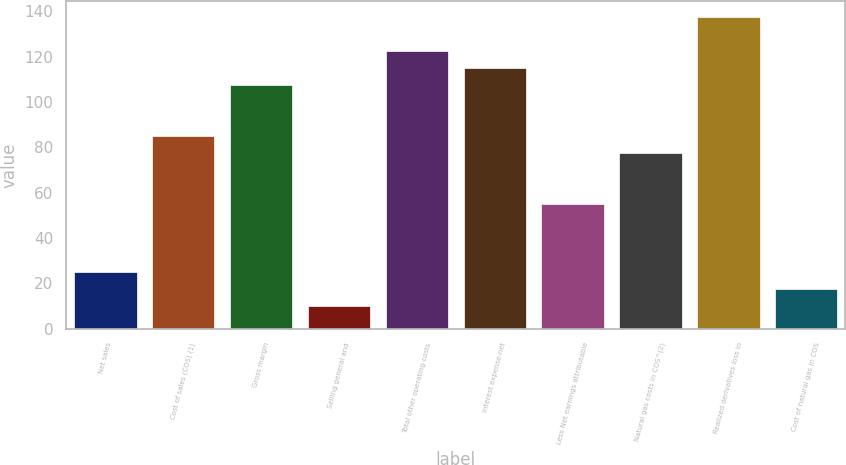Convert chart to OTSL. <chart><loc_0><loc_0><loc_500><loc_500><bar_chart><fcel>Net sales<fcel>Cost of sales (COS) (1)<fcel>Gross margin<fcel>Selling general and<fcel>Total other operating costs<fcel>Interest expense-net<fcel>Less Net earnings attributable<fcel>Natural gas costs in COS^(2)<fcel>Realized derivatives loss in<fcel>Cost of natural gas in COS<nl><fcel>25<fcel>85<fcel>107.5<fcel>10<fcel>122.5<fcel>115<fcel>55<fcel>77.5<fcel>137.5<fcel>17.5<nl></chart> 